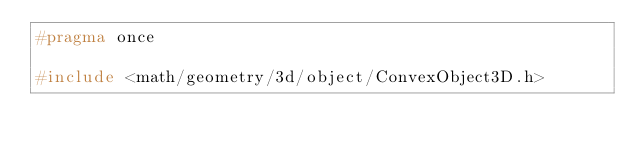Convert code to text. <code><loc_0><loc_0><loc_500><loc_500><_C_>#pragma once

#include <math/geometry/3d/object/ConvexObject3D.h></code> 